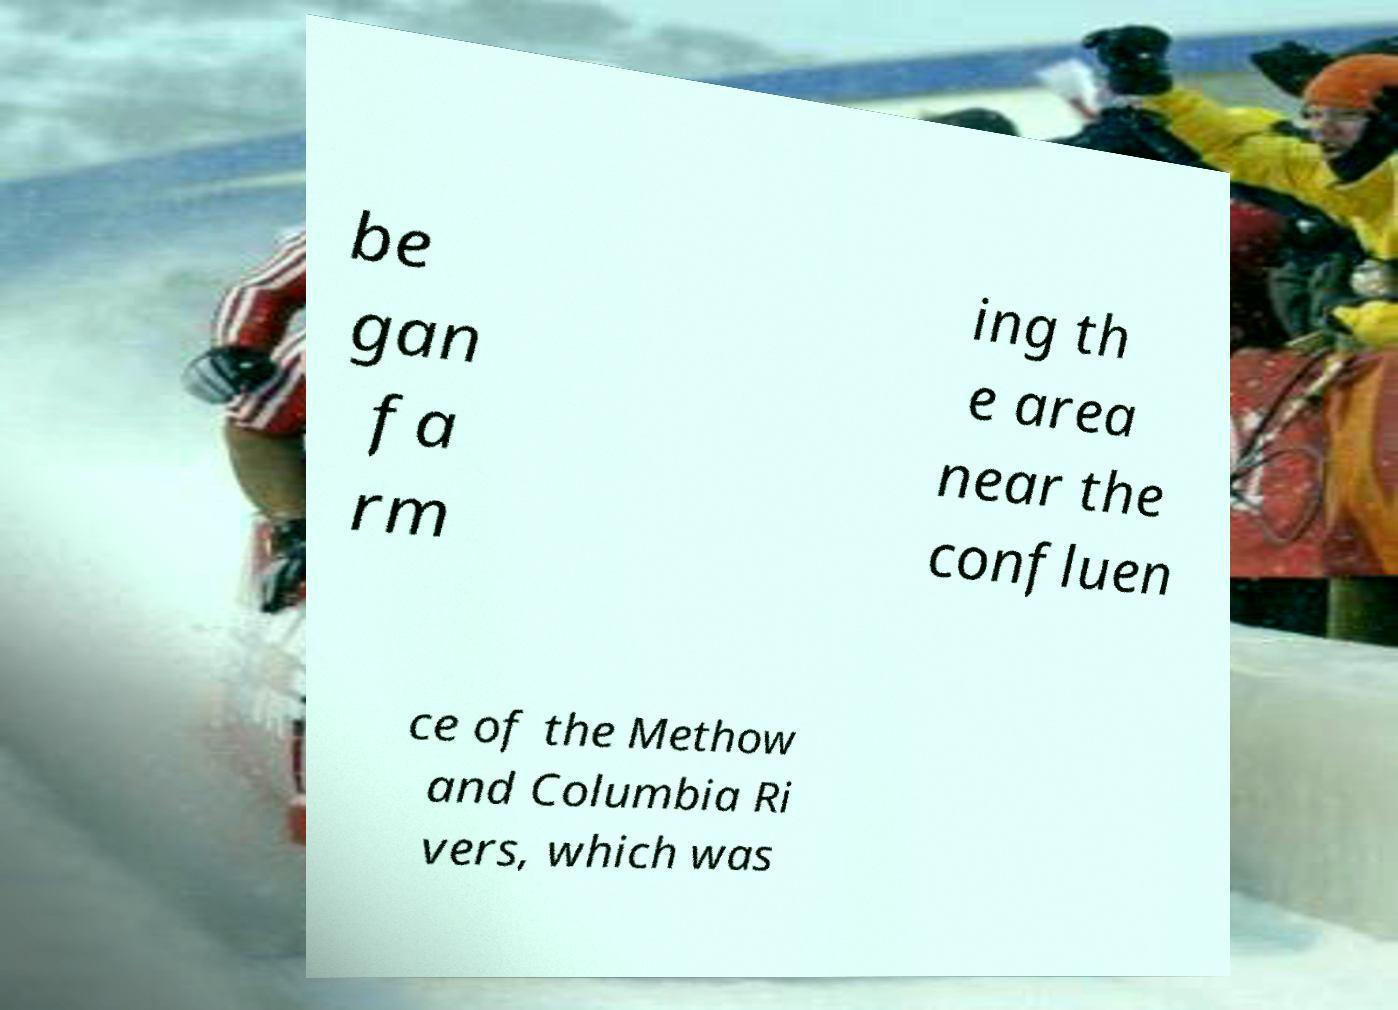What messages or text are displayed in this image? I need them in a readable, typed format. be gan fa rm ing th e area near the confluen ce of the Methow and Columbia Ri vers, which was 